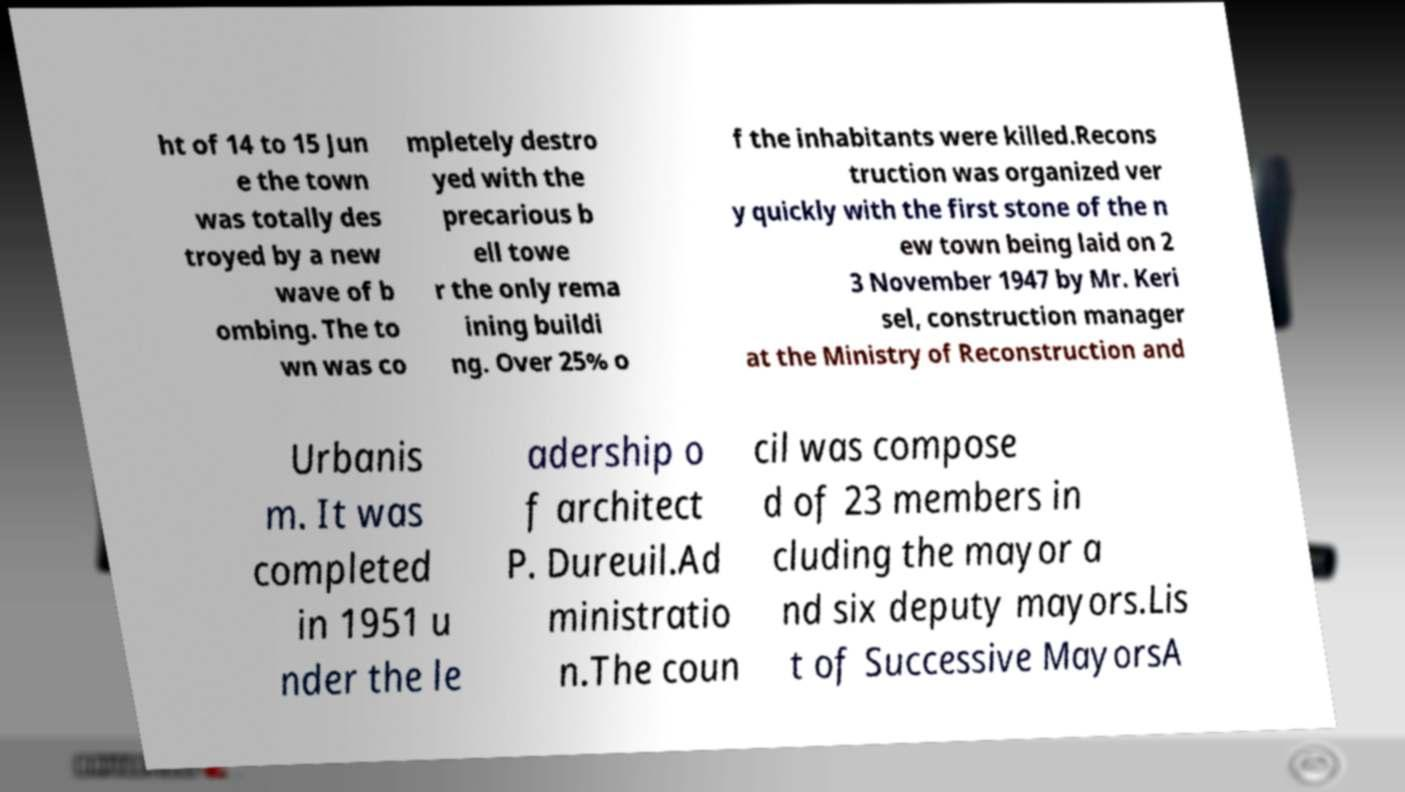Please identify and transcribe the text found in this image. ht of 14 to 15 Jun e the town was totally des troyed by a new wave of b ombing. The to wn was co mpletely destro yed with the precarious b ell towe r the only rema ining buildi ng. Over 25% o f the inhabitants were killed.Recons truction was organized ver y quickly with the first stone of the n ew town being laid on 2 3 November 1947 by Mr. Keri sel, construction manager at the Ministry of Reconstruction and Urbanis m. It was completed in 1951 u nder the le adership o f architect P. Dureuil.Ad ministratio n.The coun cil was compose d of 23 members in cluding the mayor a nd six deputy mayors.Lis t of Successive MayorsA 